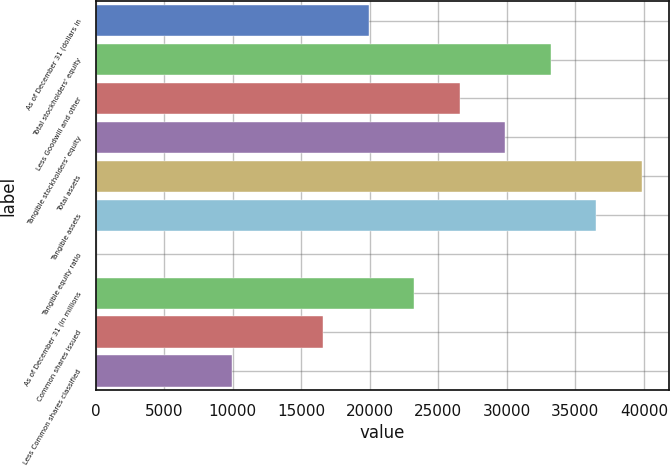Convert chart to OTSL. <chart><loc_0><loc_0><loc_500><loc_500><bar_chart><fcel>As of December 31 (dollars in<fcel>Total stockholders' equity<fcel>Less Goodwill and other<fcel>Tangible stockholders' equity<fcel>Total assets<fcel>Tangible assets<fcel>Tangible equity ratio<fcel>As of December 31 (in millions<fcel>Common shares issued<fcel>Less Common shares classified<nl><fcel>19931.6<fcel>33214<fcel>26572.8<fcel>29893.4<fcel>39855.2<fcel>36534.6<fcel>7.9<fcel>23252.2<fcel>16611<fcel>9969.73<nl></chart> 